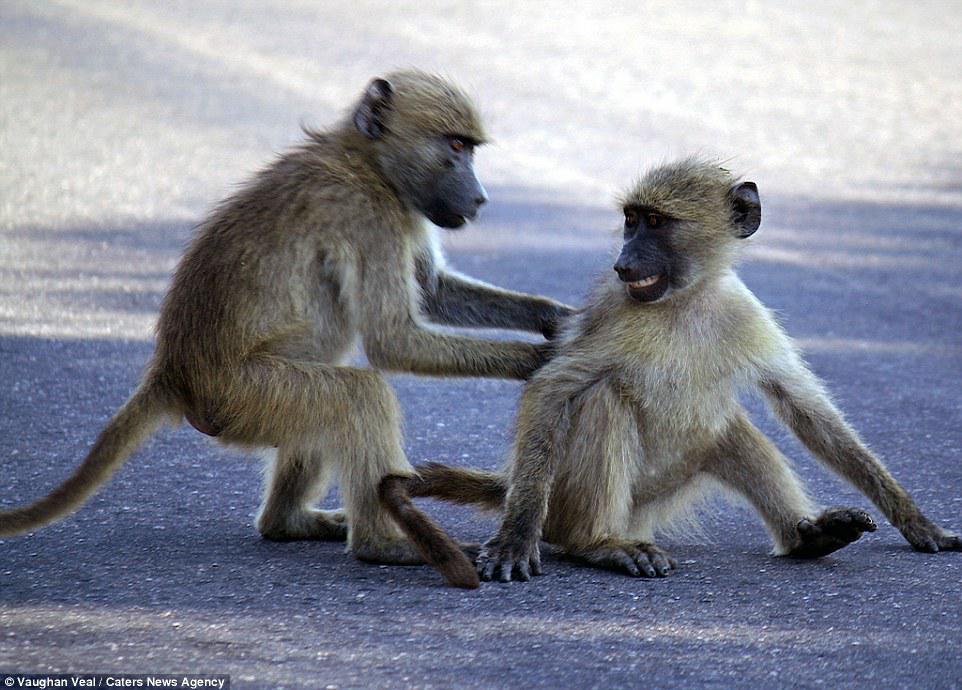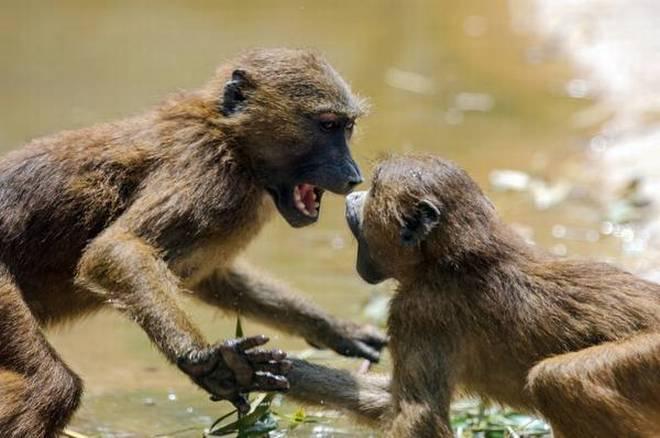The first image is the image on the left, the second image is the image on the right. For the images displayed, is the sentence "An image contains two open-mouthed monkeys posed face-to-face." factually correct? Answer yes or no. Yes. 